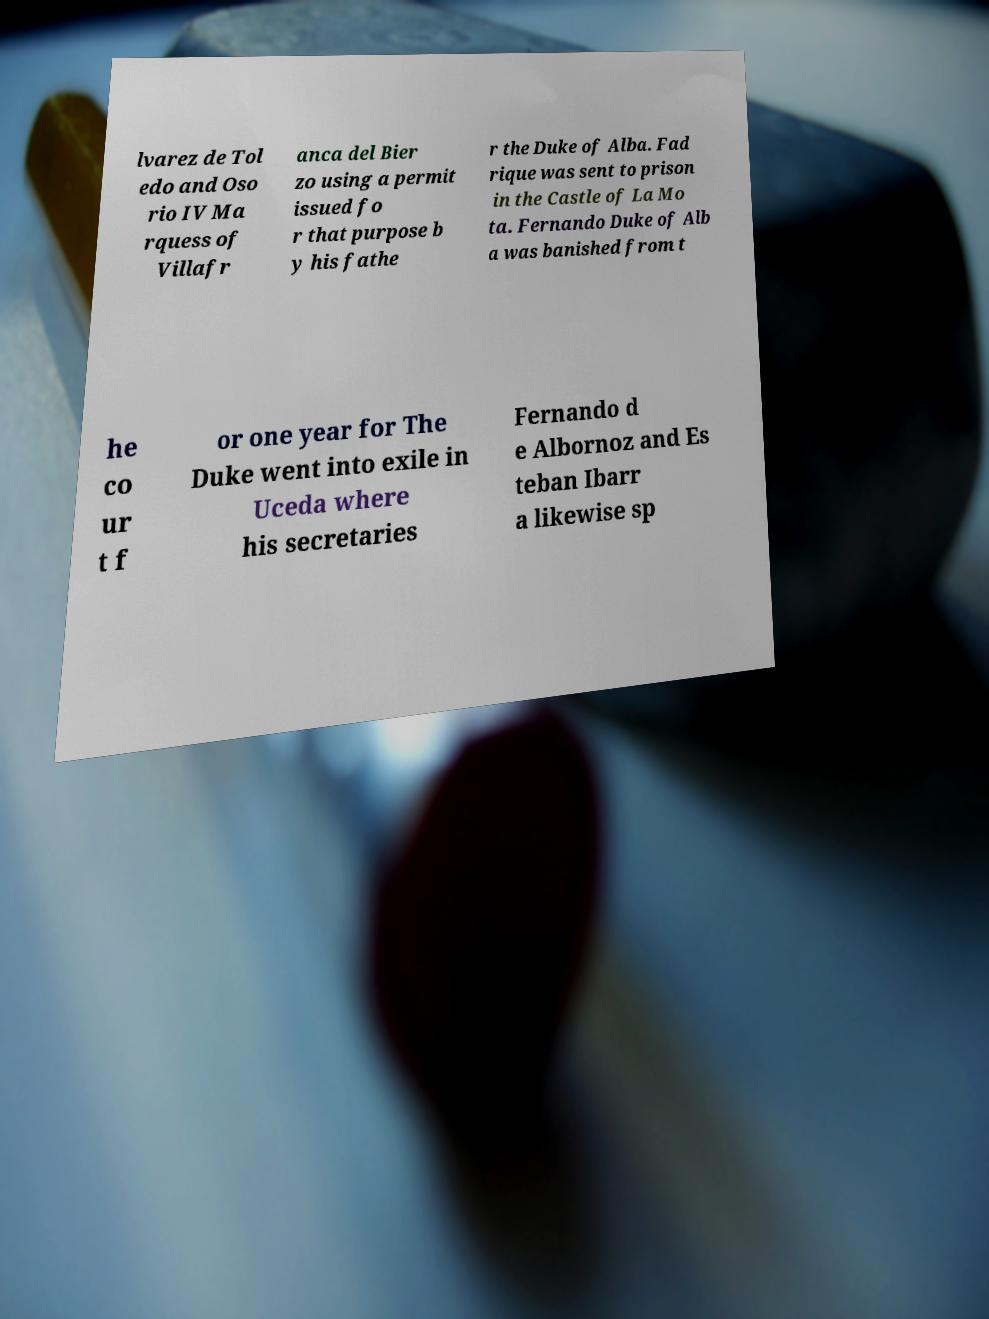Can you read and provide the text displayed in the image?This photo seems to have some interesting text. Can you extract and type it out for me? lvarez de Tol edo and Oso rio IV Ma rquess of Villafr anca del Bier zo using a permit issued fo r that purpose b y his fathe r the Duke of Alba. Fad rique was sent to prison in the Castle of La Mo ta. Fernando Duke of Alb a was banished from t he co ur t f or one year for The Duke went into exile in Uceda where his secretaries Fernando d e Albornoz and Es teban Ibarr a likewise sp 